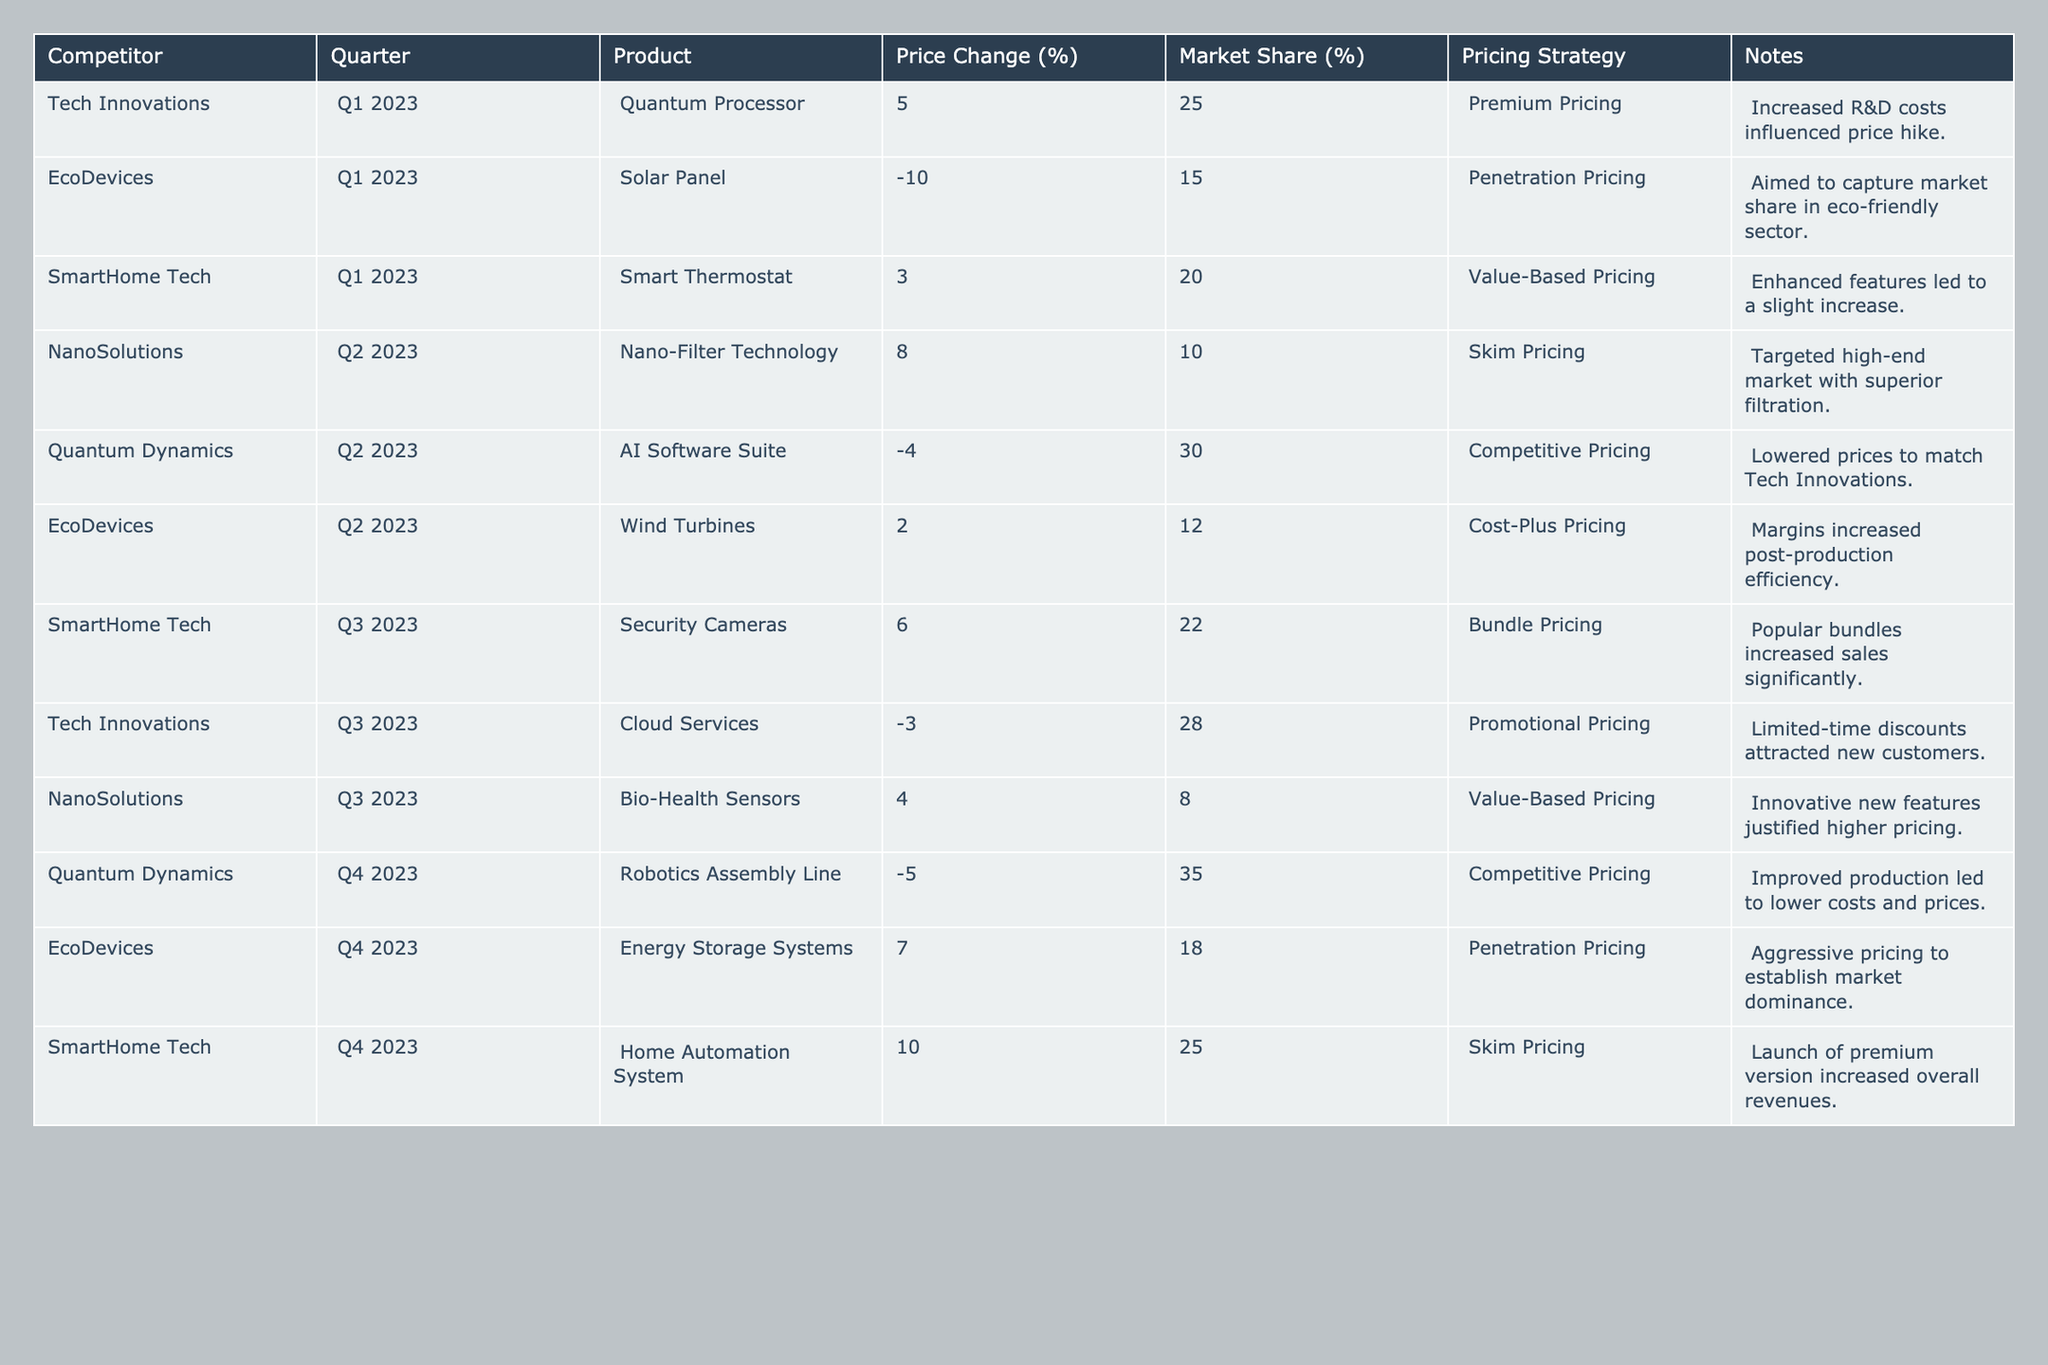What was the price change for SmartHome Tech's Smart Thermostat in Q1 2023? The price change for SmartHome Tech's Smart Thermostat in Q1 2023 is listed in the table as +3%.
Answer: +3% Which competitor had the highest market share in Q2 2023? In Q2 2023, Quantum Dynamics had the highest market share at 30%.
Answer: Quantum Dynamics What is the average price change across all competitors in Q4 2023? The price changes for Q4 2023 are -5%, +7%, and +10%. Calculating the average: (-5 + 7 + 10) / 3 = 4. So, the average price change is 4%.
Answer: 4% Did EcoDevices employ a penetration pricing strategy in Q4 2023? According to the table, EcoDevices used a penetration pricing strategy for Energy Storage Systems in Q4 2023.
Answer: Yes Which competitor had a negative price change in Q3 2023? The table indicates that Tech Innovations had a price change of -3% for Cloud Services in Q3 2023.
Answer: Tech Innovations What product did NanoSolutions launch in Q3 2023, and what was its market share? In Q3 2023, NanoSolutions launched the Bio-Health Sensors, which had a market share of 8%.
Answer: Bio-Health Sensors, 8% What pricing strategy was used by Quantum Dynamics in Q4 2023, and how did it affect their market share? Quantum Dynamics used competitive pricing in Q4 2023, and as a result, their market share increased to 35%.
Answer: Competitive Pricing, 35% Which competitor increased their prices most in Q3 2023, and by how much? The competitor that increased their prices the most in Q3 2023 is SmartHome Tech, with a price change of +10%.
Answer: SmartHome Tech, +10% Calculate the total market share for EcoDevices across all quarters. In total, EcoDevices' market share for Q1 is 15%, for Q2 is 12%, for Q4 is 18%. Summing these gives 15 + 12 + 18 = 45%.
Answer: 45% Was any competitor's pricing strategy consistently premium throughout the year? No, only Tech Innovations used premium pricing in Q1, and no competitor maintained a consistent premium strategy throughout the year.
Answer: No In which quarter did SmartHome Tech see an increase in price for their product, and what was the percentage? SmartHome Tech saw an increase in price in Q3 2023 for Security Cameras, with a price change of +6%.
Answer: Q3 2023, +6% 